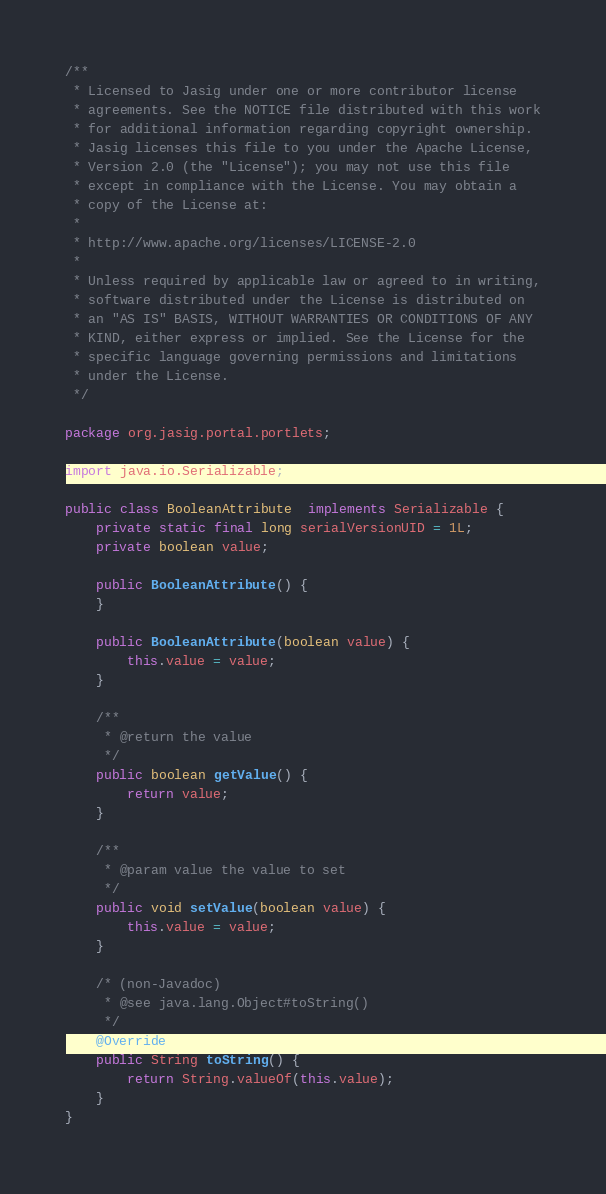Convert code to text. <code><loc_0><loc_0><loc_500><loc_500><_Java_>/**
 * Licensed to Jasig under one or more contributor license
 * agreements. See the NOTICE file distributed with this work
 * for additional information regarding copyright ownership.
 * Jasig licenses this file to you under the Apache License,
 * Version 2.0 (the "License"); you may not use this file
 * except in compliance with the License. You may obtain a
 * copy of the License at:
 *
 * http://www.apache.org/licenses/LICENSE-2.0
 *
 * Unless required by applicable law or agreed to in writing,
 * software distributed under the License is distributed on
 * an "AS IS" BASIS, WITHOUT WARRANTIES OR CONDITIONS OF ANY
 * KIND, either express or implied. See the License for the
 * specific language governing permissions and limitations
 * under the License.
 */

package org.jasig.portal.portlets;

import java.io.Serializable;

public class BooleanAttribute  implements Serializable {
    private static final long serialVersionUID = 1L;
    private boolean value;
    
    public BooleanAttribute() {
    }
    
    public BooleanAttribute(boolean value) {
        this.value = value;
    }

    /**
     * @return the value
     */
    public boolean getValue() {
        return value;
    }

    /**
     * @param value the value to set
     */
    public void setValue(boolean value) {
        this.value = value;
    }

    /* (non-Javadoc)
     * @see java.lang.Object#toString()
     */
    @Override
    public String toString() {
        return String.valueOf(this.value);
    }
}</code> 